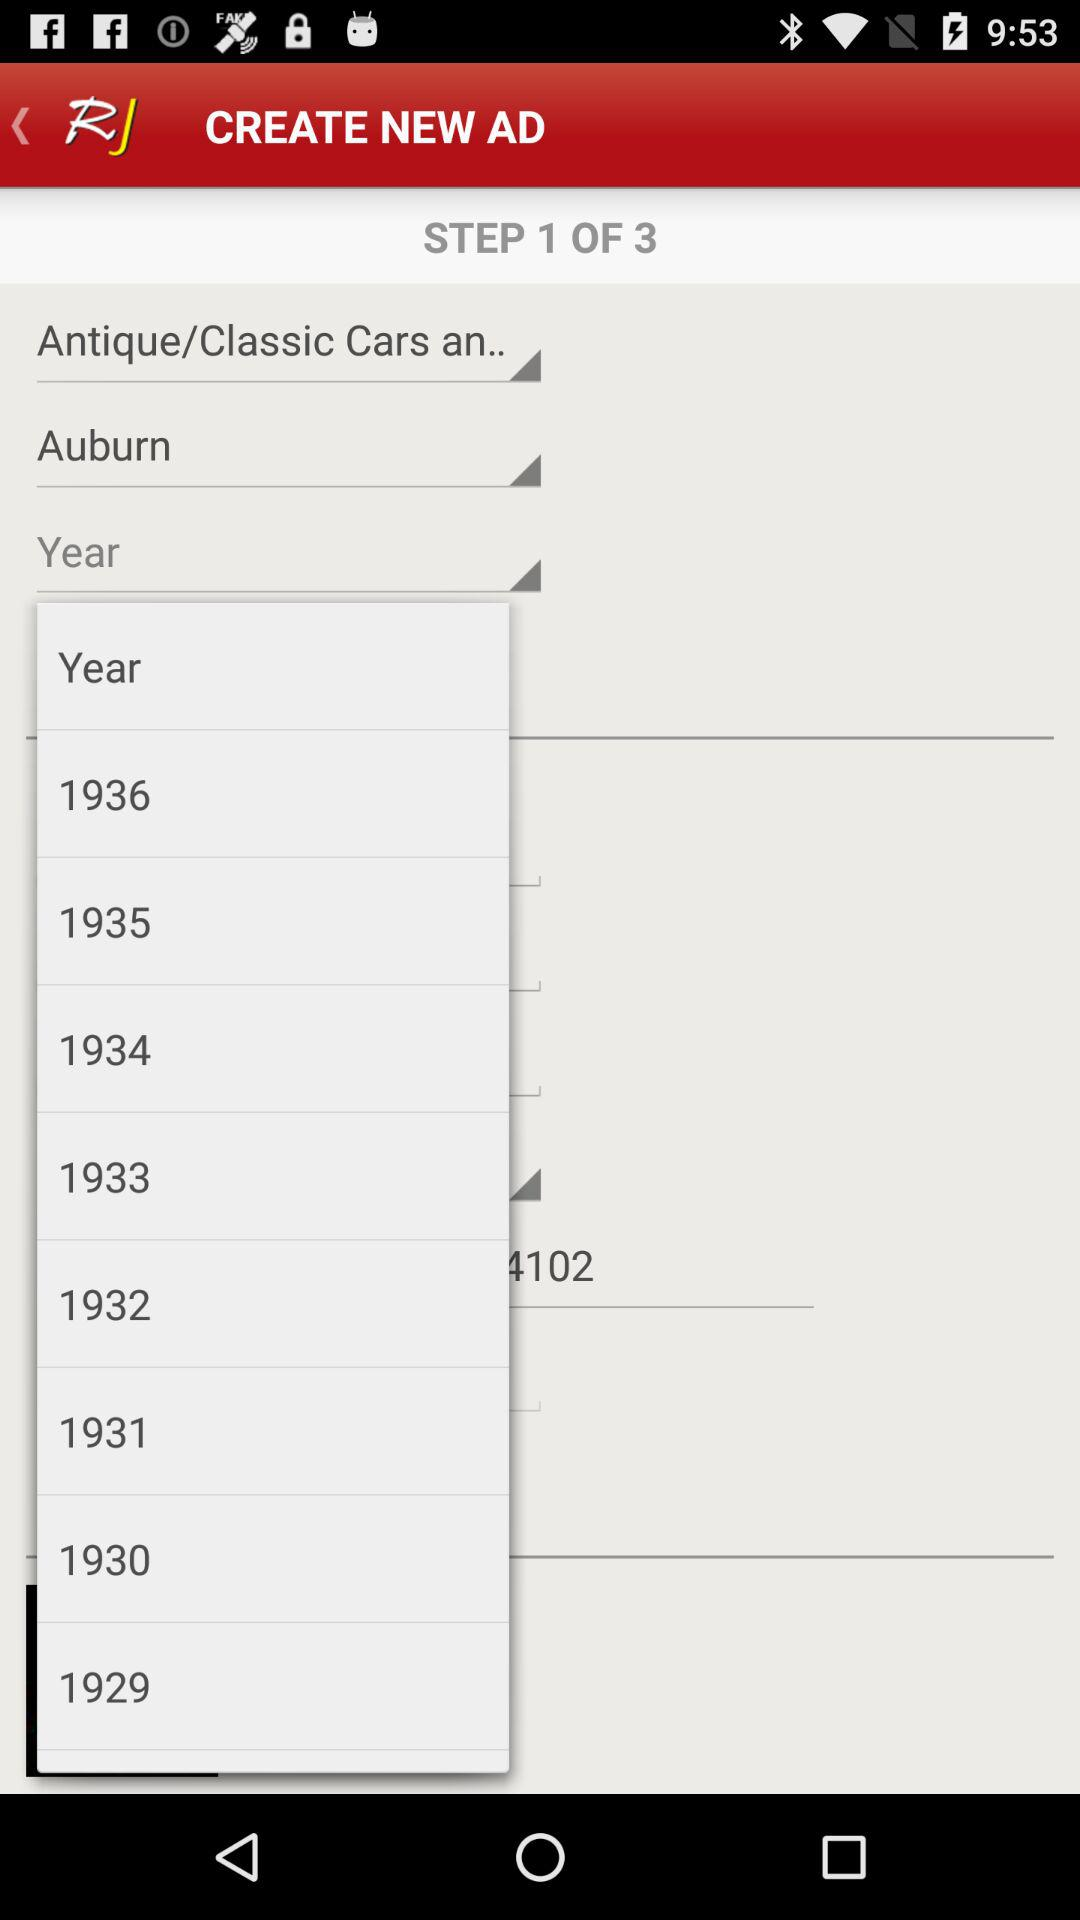What is the application name? The application name is "RJ". 